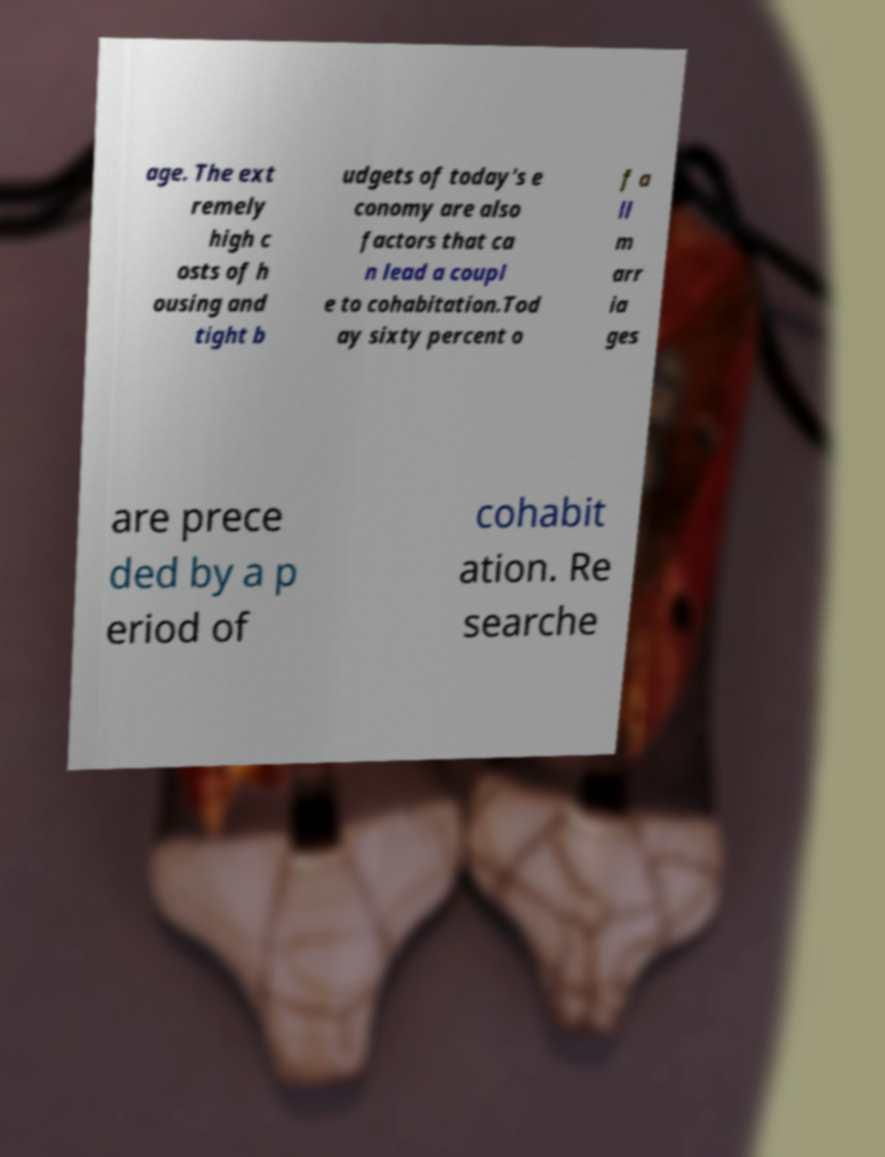Please identify and transcribe the text found in this image. age. The ext remely high c osts of h ousing and tight b udgets of today's e conomy are also factors that ca n lead a coupl e to cohabitation.Tod ay sixty percent o f a ll m arr ia ges are prece ded by a p eriod of cohabit ation. Re searche 